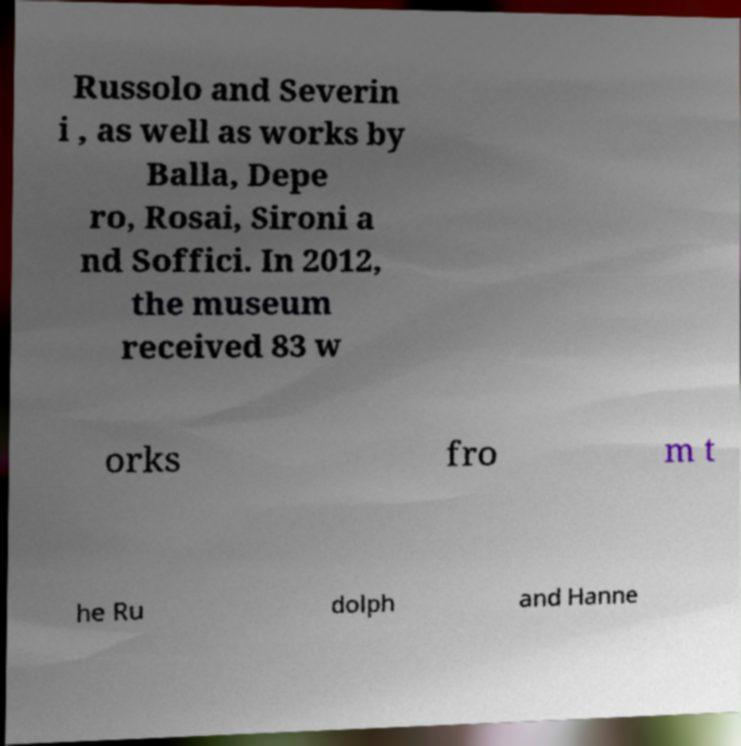What messages or text are displayed in this image? I need them in a readable, typed format. Russolo and Severin i , as well as works by Balla, Depe ro, Rosai, Sironi a nd Soffici. In 2012, the museum received 83 w orks fro m t he Ru dolph and Hanne 